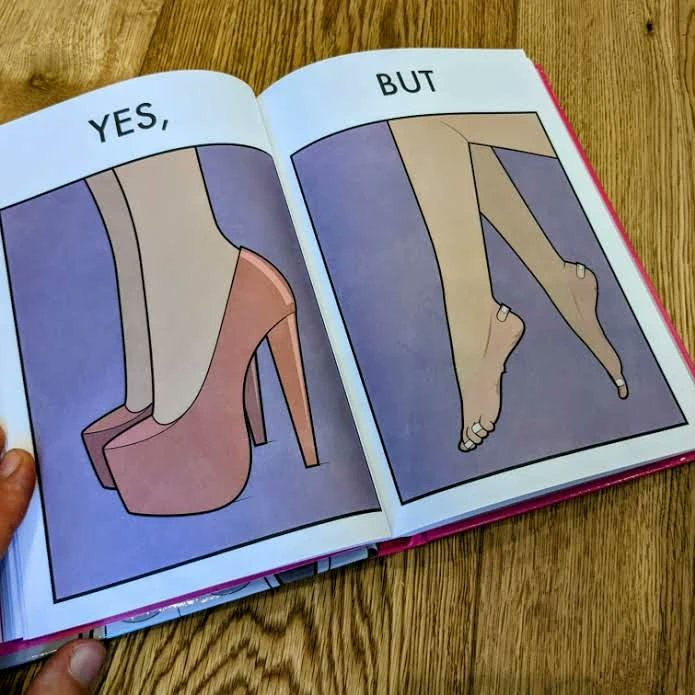Explain why this image is satirical. The images are funny since they show how the prettiest footwears like high heels, end up causing a lot of physical discomfort to the user, all in the name fashion 